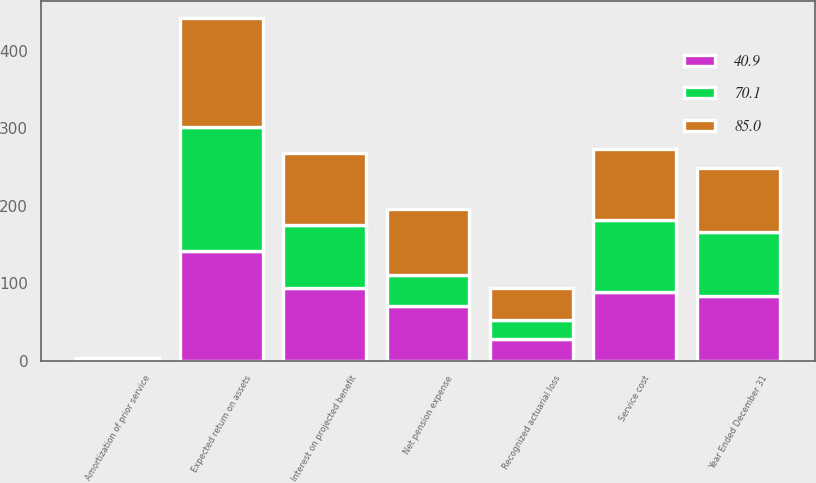Convert chart to OTSL. <chart><loc_0><loc_0><loc_500><loc_500><stacked_bar_chart><ecel><fcel>Year Ended December 31<fcel>Service cost<fcel>Interest on projected benefit<fcel>Expected return on assets<fcel>Amortization of prior service<fcel>Recognized actuarial loss<fcel>Net pension expense<nl><fcel>70.1<fcel>83.05<fcel>92.9<fcel>81.1<fcel>159.7<fcel>1.2<fcel>25.4<fcel>40.9<nl><fcel>40.9<fcel>83.05<fcel>88.6<fcel>94.3<fcel>141.7<fcel>1.2<fcel>27.7<fcel>70.1<nl><fcel>85<fcel>83.05<fcel>91.3<fcel>92.2<fcel>140.8<fcel>1.3<fcel>41.1<fcel>85<nl></chart> 